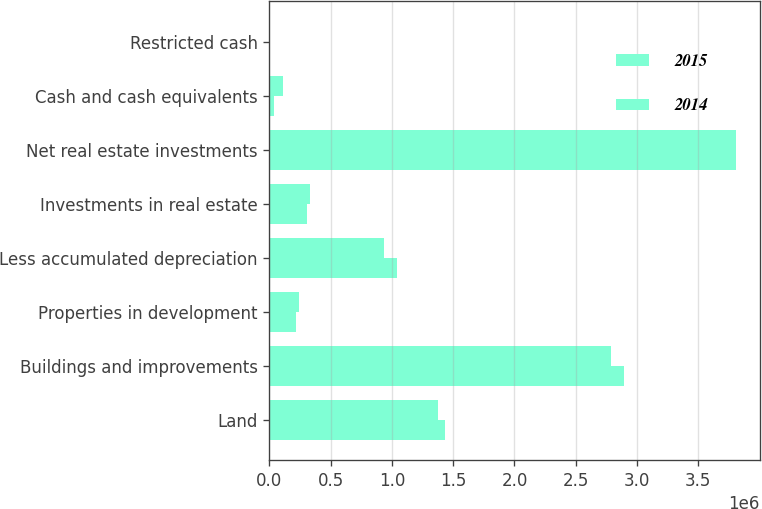<chart> <loc_0><loc_0><loc_500><loc_500><stacked_bar_chart><ecel><fcel>Land<fcel>Buildings and improvements<fcel>Properties in development<fcel>Less accumulated depreciation<fcel>Investments in real estate<fcel>Net real estate investments<fcel>Cash and cash equivalents<fcel>Restricted cash<nl><fcel>2015<fcel>1.43247e+06<fcel>2.8964e+06<fcel>217036<fcel>1.04379e+06<fcel>306206<fcel>3.80832e+06<fcel>36856<fcel>3767<nl><fcel>2014<fcel>1.38021e+06<fcel>2.79014e+06<fcel>239538<fcel>933708<fcel>333167<fcel>3.80934e+06<fcel>113776<fcel>8013<nl></chart> 